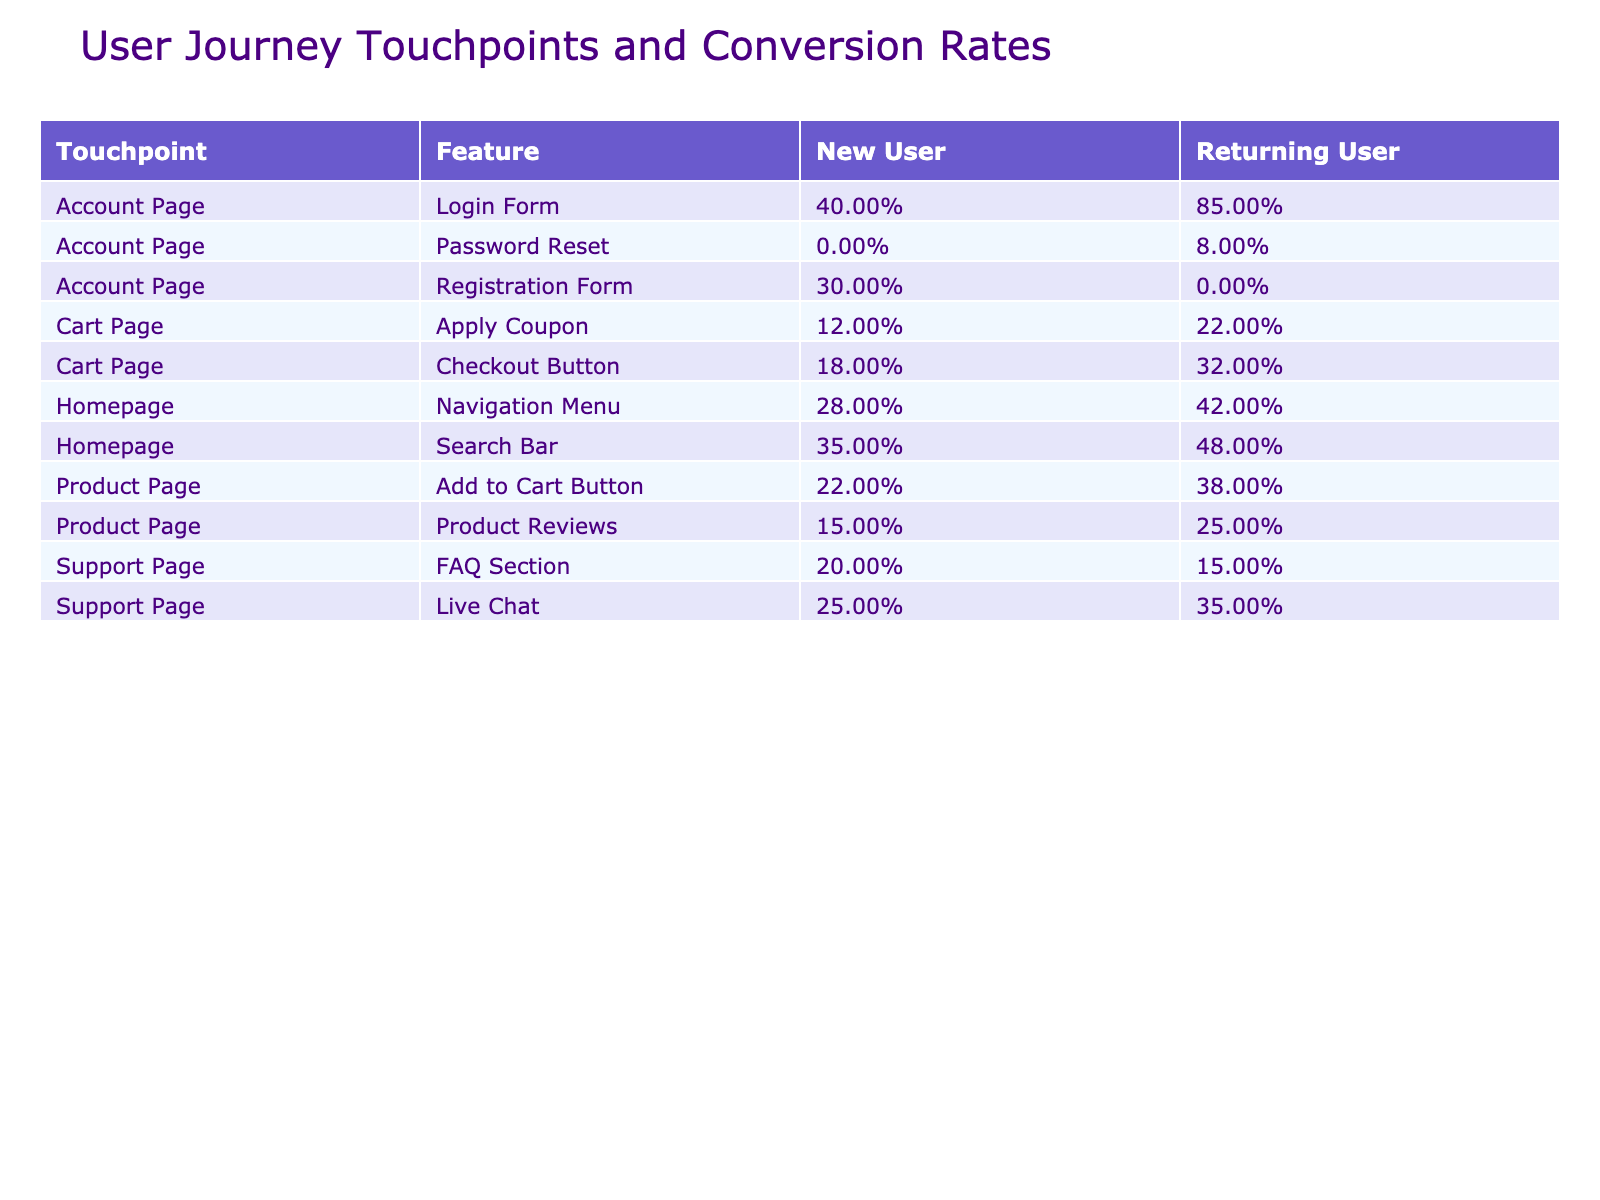What is the conversion rate for the Homepage Search Bar for New Users? The table explicitly lists the conversion rate for the Homepage Search Bar under the New User category as 0.35.
Answer: 0.35 What is the conversion rate for the Returning Users on the Cart Page's Checkout Button? From the table, the conversion rate for Returning Users on the Cart Page's Checkout Button is directly stated as 0.32.
Answer: 0.32 Which feature has the highest conversion rate for Returning Users? By comparing the conversion rates for Returning Users from all features, the Login Form on the Account Page has the highest conversion rate at 0.85.
Answer: 0.85 What is the difference between the conversion rates of New Users and Returning Users on the Product Page's Add to Cart Button? The conversion rate for New Users is 0.22 and for Returning Users it is 0.38. The difference is calculated as 0.38 - 0.22 = 0.16.
Answer: 0.16 Is the conversion rate for New Users on the Cart Page's Apply Coupon greater than that of Returning Users? The conversion rate for New Users on the Apply Coupon feature is 0.12, while for Returning Users it is 0.22. Since 0.12 < 0.22, the statement is false.
Answer: No What is the average conversion rate for the Support Page's Live Chat feature across both user types? The conversion rates for the Support Page's Live Chat are 0.25 (New Users) and 0.35 (Returning Users). The average is calculated as (0.25 + 0.35) / 2 = 0.30.
Answer: 0.30 What feature performed better for New Users on the Homepage, the Search Bar or the Navigation Menu? The conversion rate of the Search Bar for New Users is 0.35, while the Navigation Menu's rate is 0.28. Since 0.35 > 0.28, the Search Bar performed better.
Answer: Search Bar How many completed actions did Returning Users accomplish on the Account Page's Login Form? The table indicates that Returning Users completed 425 actions using the Login Form.
Answer: 425 What is the total number of completed actions for New Users on the Cart Page? The completed actions for New Users on the Cart Page comprise those for the Checkout Button (90) and Apply Coupon (60). Thus, the total is 90 + 60 = 150.
Answer: 150 